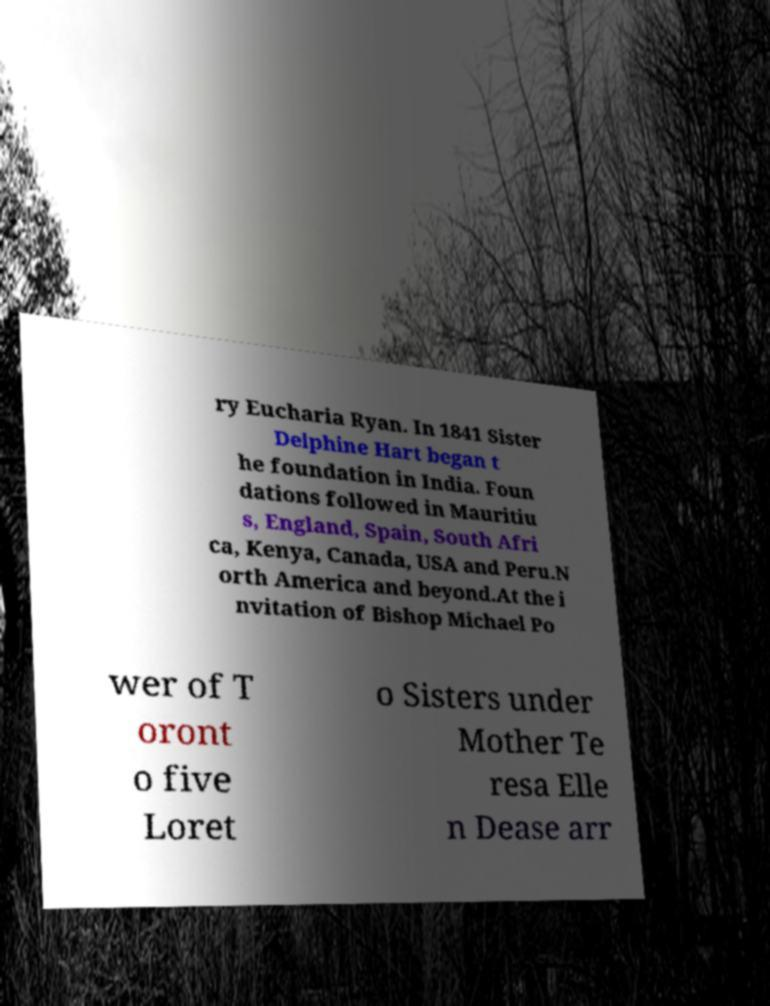Can you read and provide the text displayed in the image?This photo seems to have some interesting text. Can you extract and type it out for me? ry Eucharia Ryan. In 1841 Sister Delphine Hart began t he foundation in India. Foun dations followed in Mauritiu s, England, Spain, South Afri ca, Kenya, Canada, USA and Peru.N orth America and beyond.At the i nvitation of Bishop Michael Po wer of T oront o five Loret o Sisters under Mother Te resa Elle n Dease arr 